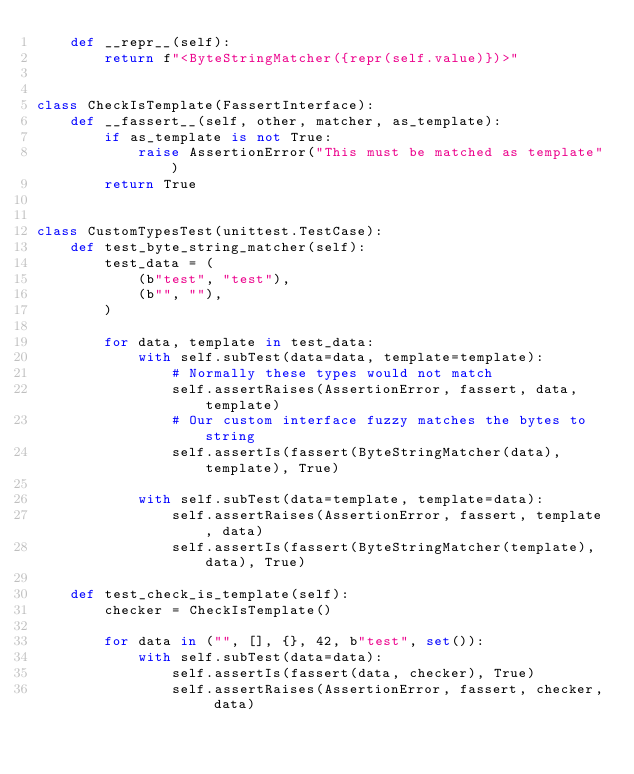<code> <loc_0><loc_0><loc_500><loc_500><_Python_>    def __repr__(self):
        return f"<ByteStringMatcher({repr(self.value)})>"


class CheckIsTemplate(FassertInterface):
    def __fassert__(self, other, matcher, as_template):
        if as_template is not True:
            raise AssertionError("This must be matched as template")
        return True


class CustomTypesTest(unittest.TestCase):
    def test_byte_string_matcher(self):
        test_data = (
            (b"test", "test"),
            (b"", ""),
        )

        for data, template in test_data:
            with self.subTest(data=data, template=template):
                # Normally these types would not match
                self.assertRaises(AssertionError, fassert, data, template)
                # Our custom interface fuzzy matches the bytes to string
                self.assertIs(fassert(ByteStringMatcher(data), template), True)

            with self.subTest(data=template, template=data):
                self.assertRaises(AssertionError, fassert, template, data)
                self.assertIs(fassert(ByteStringMatcher(template), data), True)

    def test_check_is_template(self):
        checker = CheckIsTemplate()

        for data in ("", [], {}, 42, b"test", set()):
            with self.subTest(data=data):
                self.assertIs(fassert(data, checker), True)
                self.assertRaises(AssertionError, fassert, checker, data)
</code> 